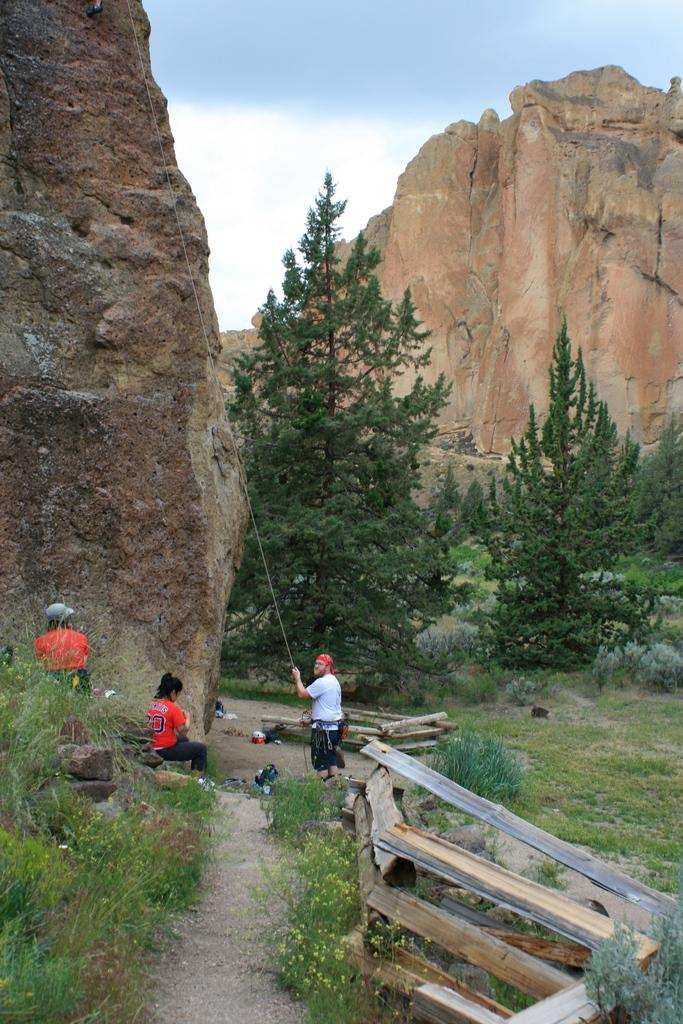Who or what can be seen in the image? There are people in the image. What type of natural elements are present in the image? There are trees, plants, grass, and mountains in the image. What is the wooden structure in the image? There is a wooden railing in the image. What is visible in the background of the image? The sky is visible in the background of the image. What type of pan can be seen on the top of the mountain in the image? There is no pan visible on the top of the mountain in the image. What type of birds are flying around the people in the image? There are no birds visible in the image. 